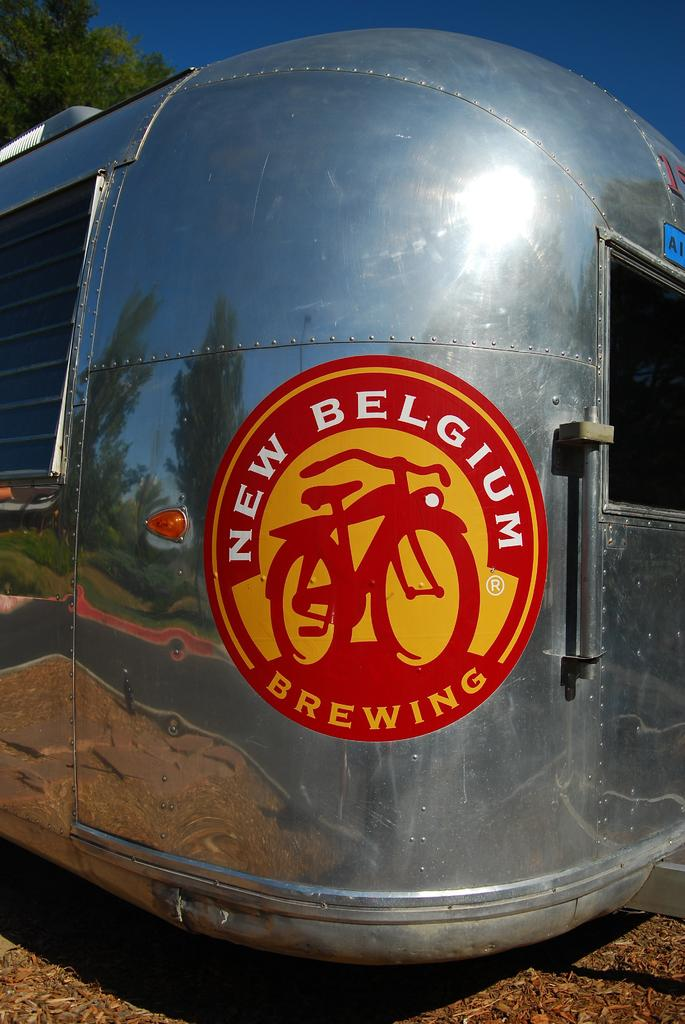What is the color of the object in the image? The object in the image is silver. What is written on the silver object? There is text written on the silver object. What can be seen in the background of the image? There is a tree in the background of the image. What type of record is being played on the silver object in the image? There is no record or any indication of music playing in the image; it only features a silver object with text on it and a tree in the background. 